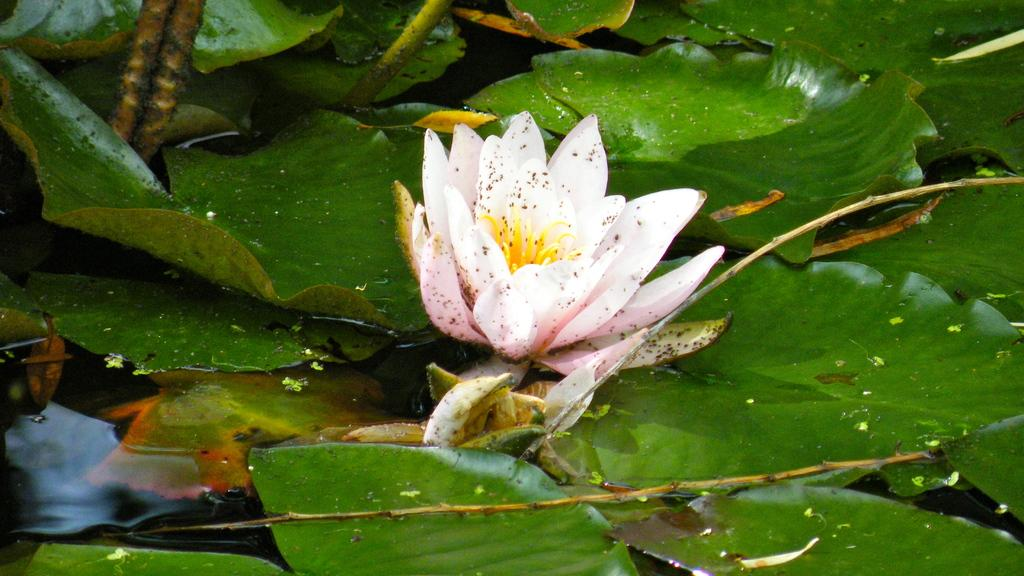What type of plant can be seen in the image? There is a flower in the image. What parts of the plant are visible in the image? There are leaves and stems in the image. What else can be seen in the image besides the plant? There is water visible in the image. What type of knot is tied around the flower in the image? There is no knot present in the image; it only features a flower, leaves, stems, and water. What surprise can be seen in the image? There is no surprise present in the image; it is a simple depiction of a flower, leaves, stems, and water. 